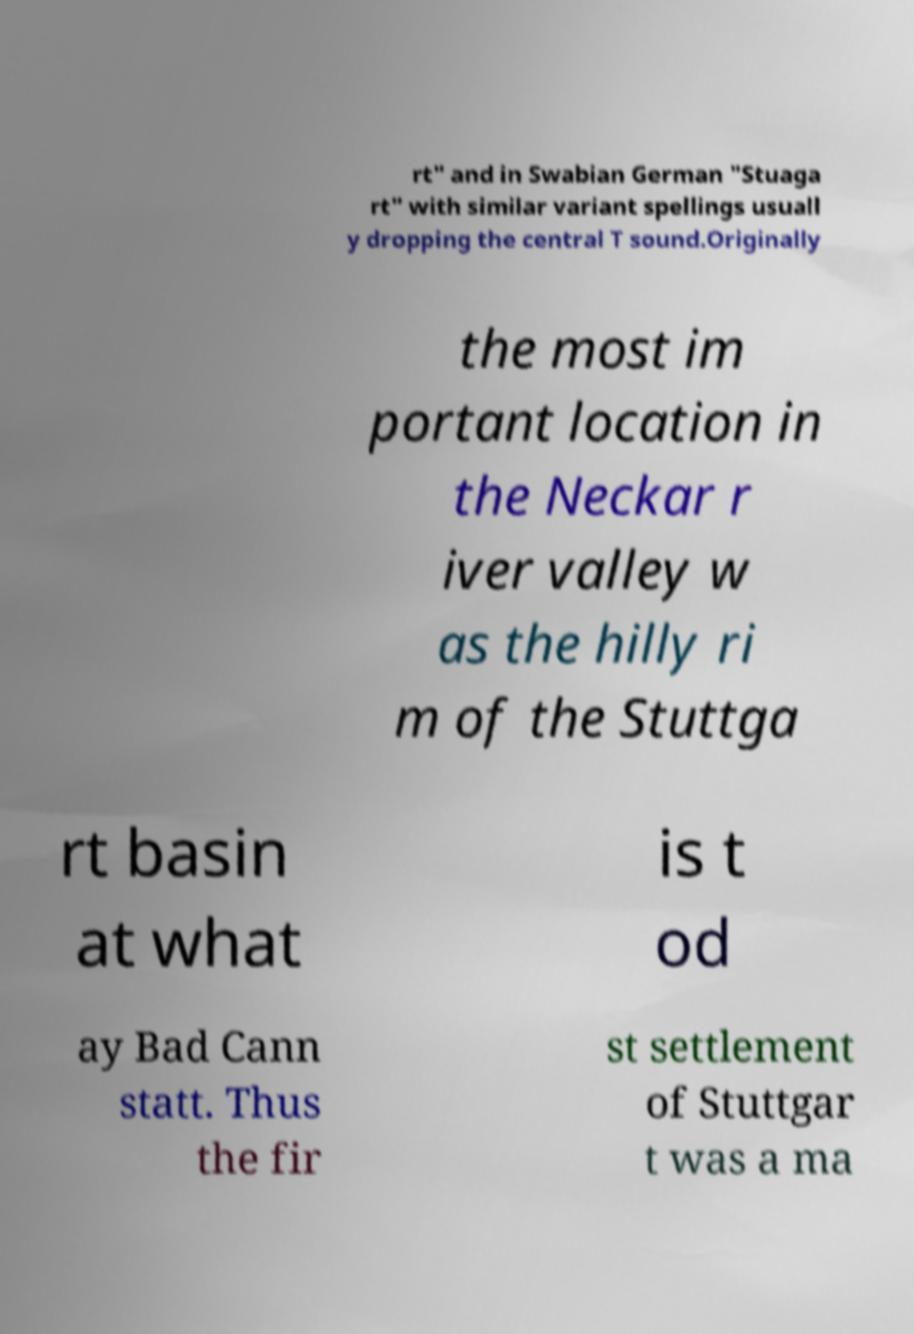There's text embedded in this image that I need extracted. Can you transcribe it verbatim? rt" and in Swabian German "Stuaga rt" with similar variant spellings usuall y dropping the central T sound.Originally the most im portant location in the Neckar r iver valley w as the hilly ri m of the Stuttga rt basin at what is t od ay Bad Cann statt. Thus the fir st settlement of Stuttgar t was a ma 